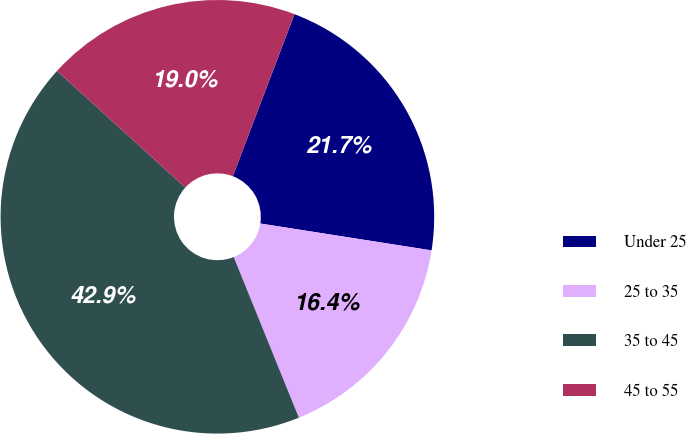Convert chart. <chart><loc_0><loc_0><loc_500><loc_500><pie_chart><fcel>Under 25<fcel>25 to 35<fcel>35 to 45<fcel>45 to 55<nl><fcel>21.69%<fcel>16.39%<fcel>42.88%<fcel>19.04%<nl></chart> 